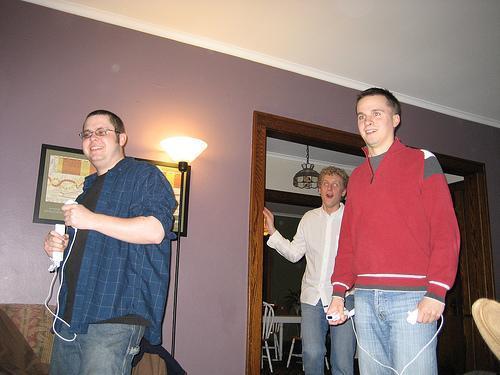How many lamps are there?
Give a very brief answer. 1. How many people are there?
Give a very brief answer. 3. 